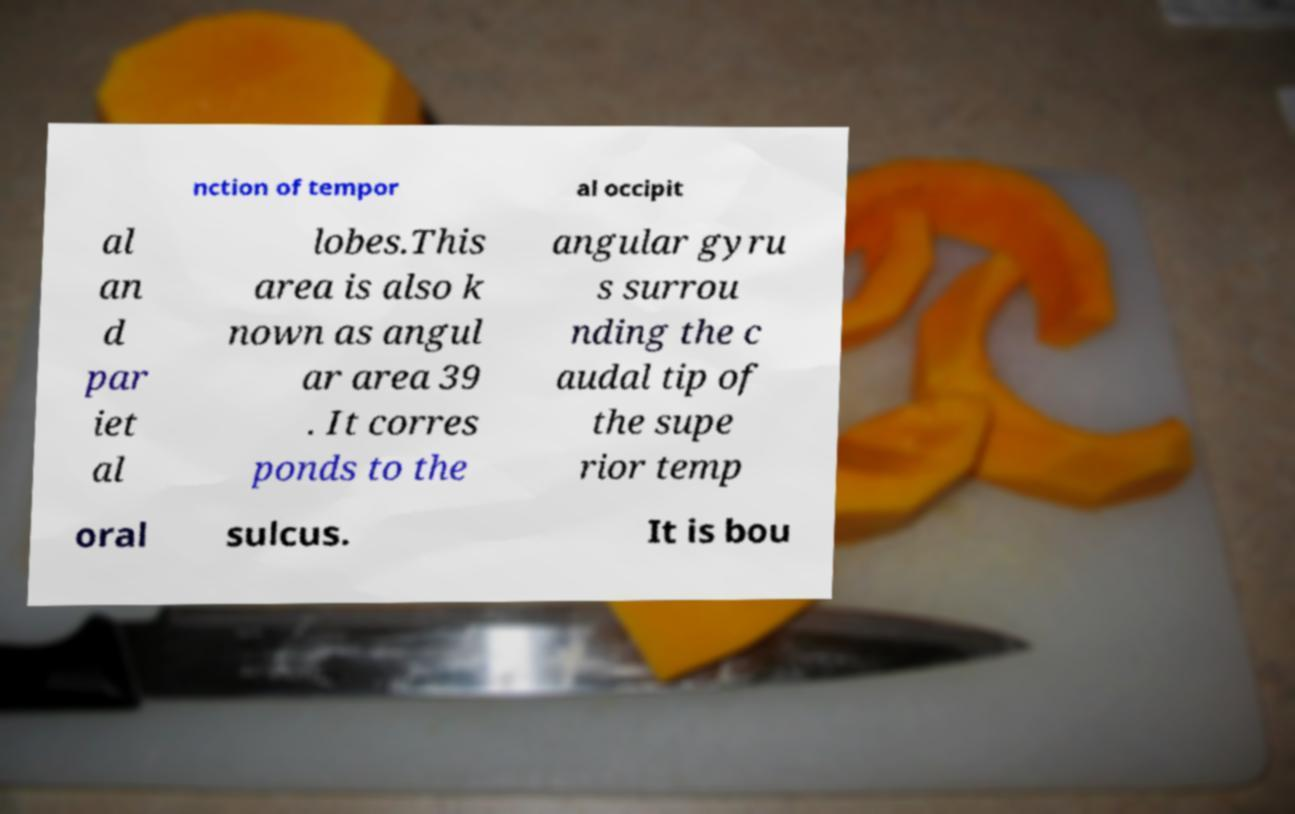Can you read and provide the text displayed in the image?This photo seems to have some interesting text. Can you extract and type it out for me? nction of tempor al occipit al an d par iet al lobes.This area is also k nown as angul ar area 39 . It corres ponds to the angular gyru s surrou nding the c audal tip of the supe rior temp oral sulcus. It is bou 